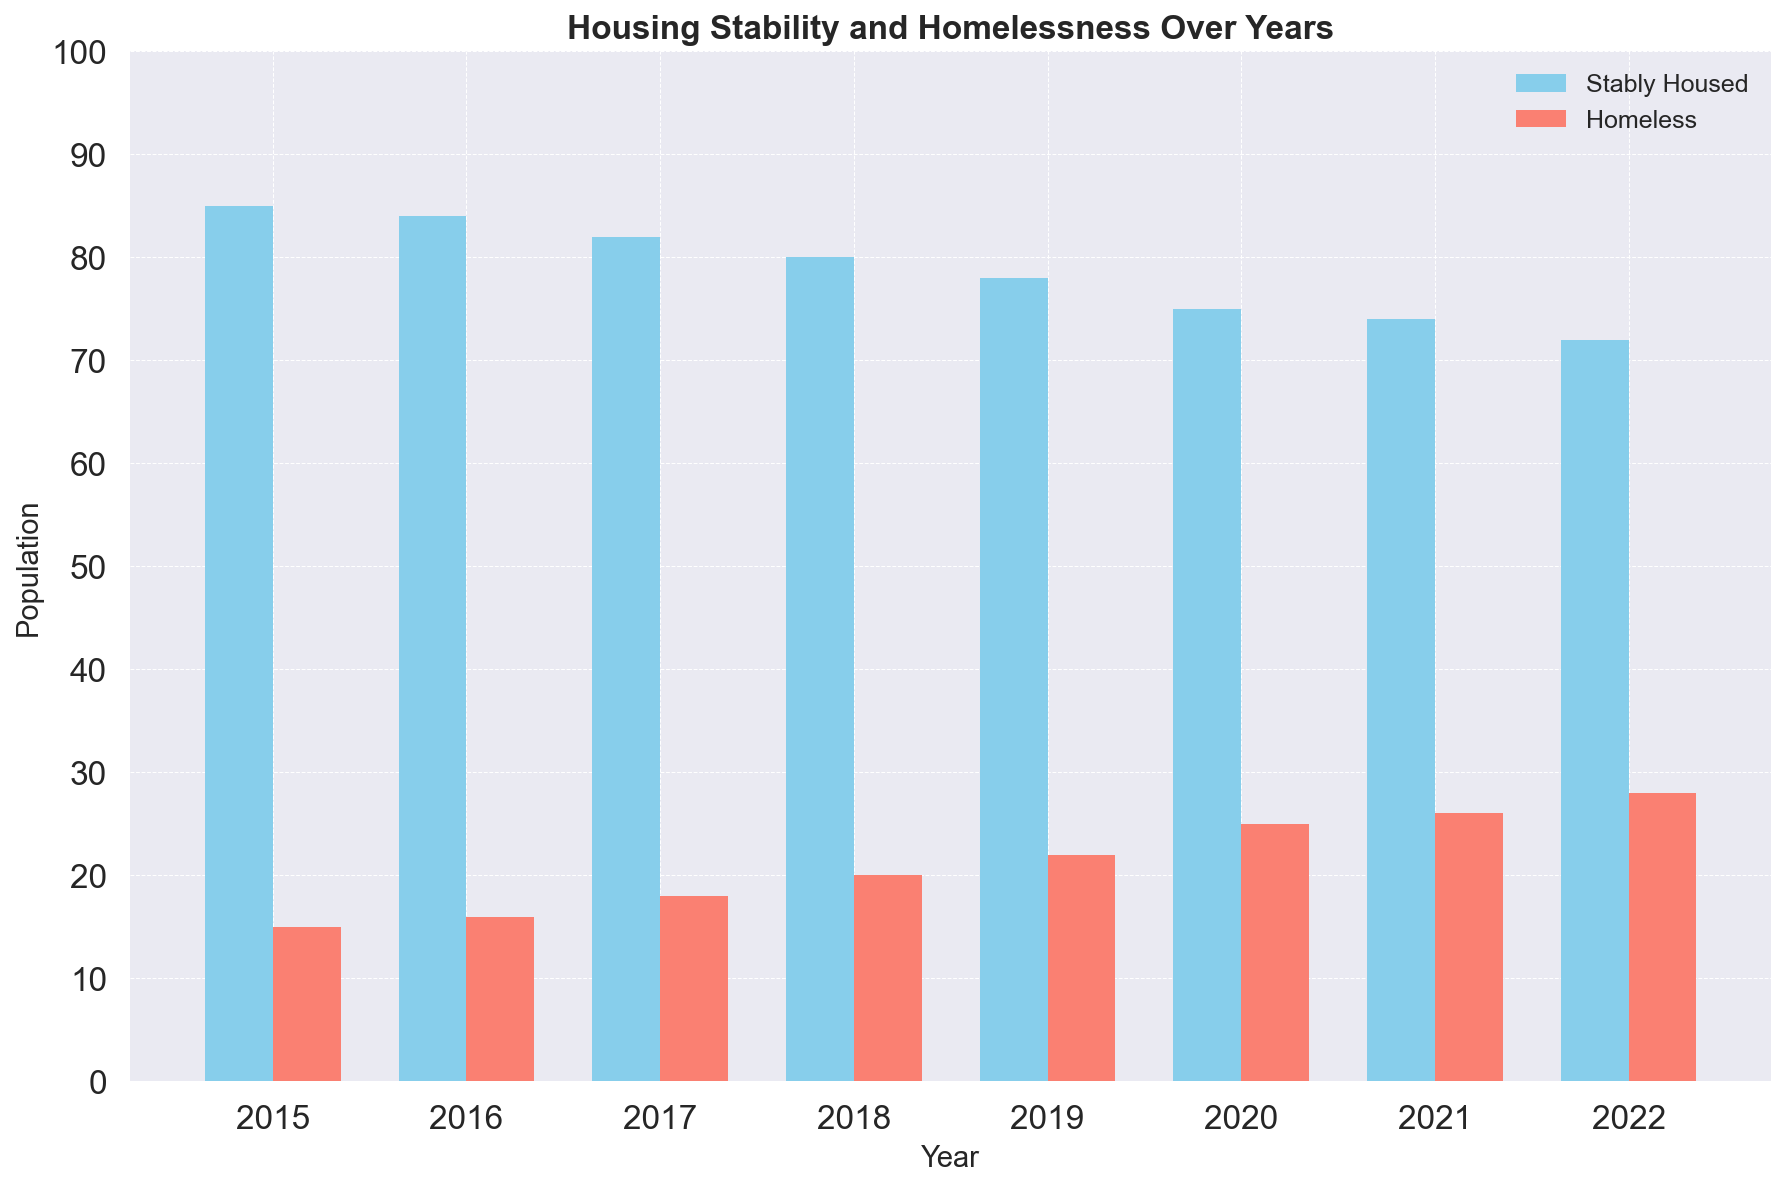What's the trend in the homeless population from 2015 to 2022? To see the trend, observe the height of the bars representing the homeless population from left (2015) to right (2022). Notice the height increases consistently each year.
Answer: Increasing What was the total number of the homeless population in the years 2018 and 2019 combined? Sum the values for homelessness in 2018 and 2019: 20 (2018) + 22 (2019) = 42.
Answer: 42 Which year had the largest gap between the stably housed and homeless populations? Calculate the difference between the bars for each year. The year with the largest difference is where the height of the stably housed bar is most significantly higher than the height of the homeless bar. The difference in 2015 is the greatest, with 85 - 15 = 70.
Answer: 2015 How does the stably housed population in 2022 compare with that in 2015? Compare the height of the stably housed bars in 2022 and 2015. The 2022 bar is shorter, indicating a decrease in population. Specifically, 85 in 2015 versus 72 in 2022.
Answer: Decreased What is the average number of homeless people from 2015 to 2022? Sum the homeless populations from 2015 to 2022 and divide by the number of years: (15 + 16 + 18 + 20 + 22 + 25 + 26 + 28) / 8 = 170 / 8 = 21.25.
Answer: 21.25 Compare the stably housed and homeless population in 2020. Which is greater and by how much? Look at the bars for 2020: Stably Housed = 75, Homeless = 25. The stably housed population is 75 - 25 = 50 greater.
Answer: Stably housed by 50 What is the total population (stably housed + homeless) recorded in 2021? Add the stably housed and homeless populations for 2021: 74 (stably housed) + 26 (homeless) = 100.
Answer: 100 Which year shows the smallest homeless population? Identify the year with the shortest bar for homeless population. The shortest homeless bar is in 2015, with a population of 15.
Answer: 2015 How did the homeless population change between 2019 and 2020? Compare the height of the homeless bars in 2019 and 2020. The homeless population increases from 22 (2019) to 25 (2020).
Answer: Increased What is the difference in the stably housed population between the first and last years in the chart? Subtract the stably housed population in 2022 from that in 2015: 85 (2015) - 72 (2022) = 13.
Answer: 13 